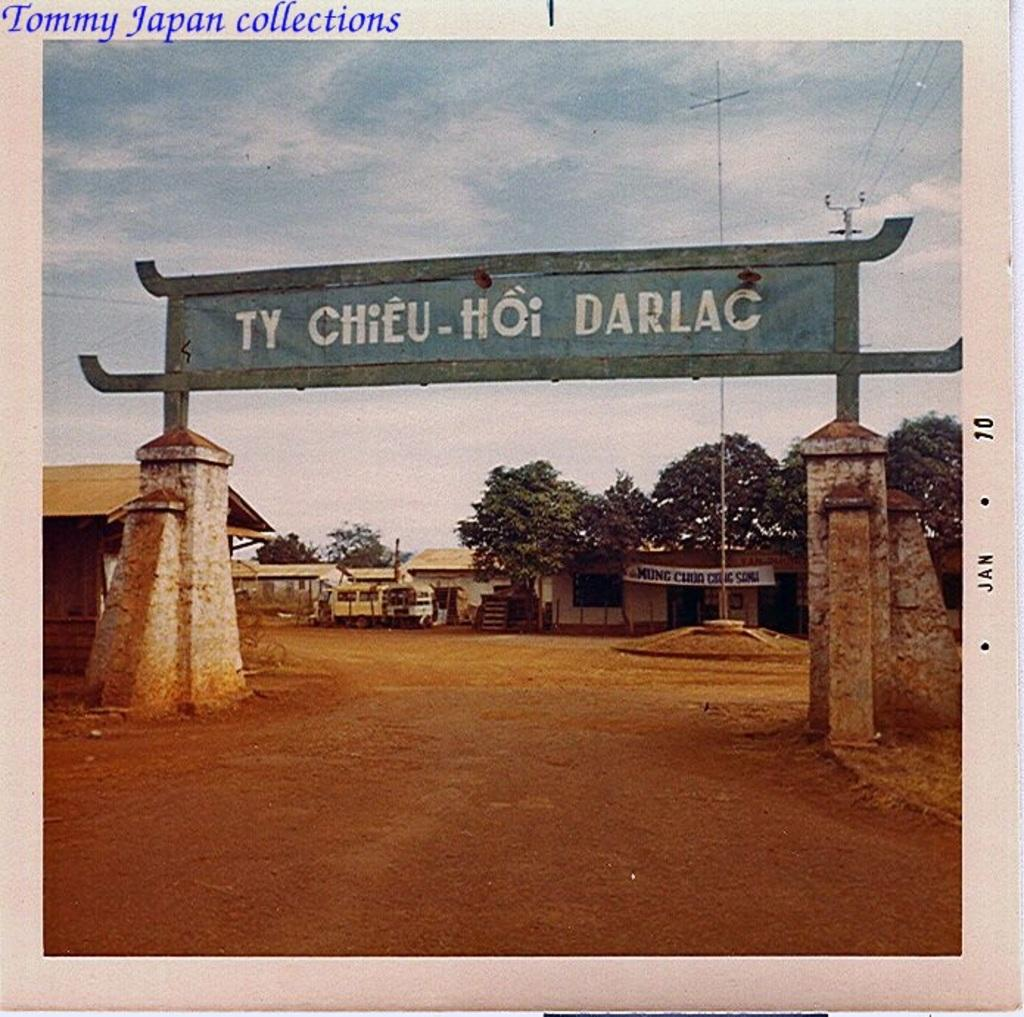<image>
Write a terse but informative summary of the picture. The entrance to Ty Chieu - Hoi Darlac is marked by a sign over a gate. 